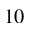Convert formula to latex. <formula><loc_0><loc_0><loc_500><loc_500>1 0</formula> 